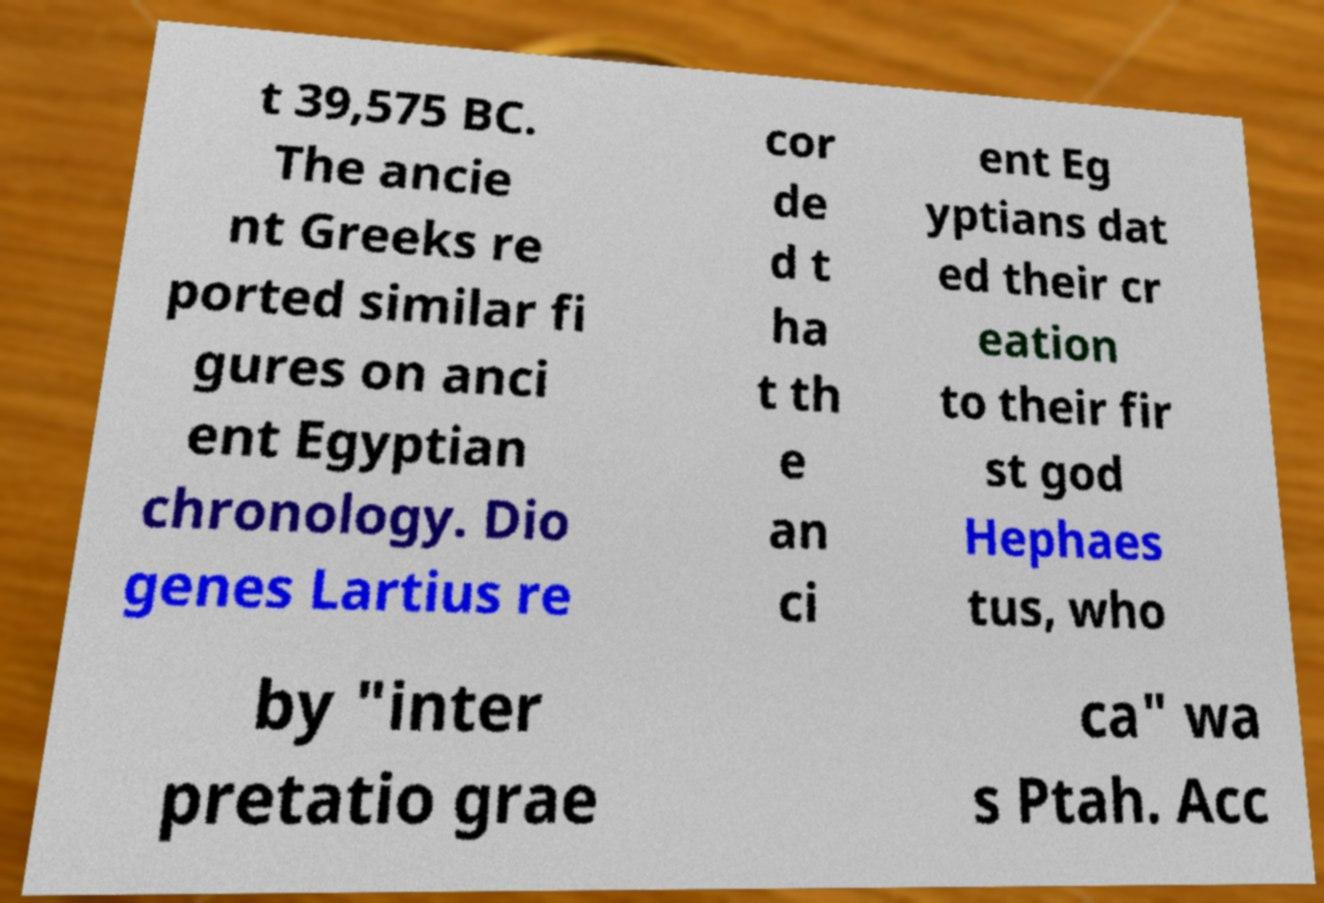Could you extract and type out the text from this image? t 39,575 BC. The ancie nt Greeks re ported similar fi gures on anci ent Egyptian chronology. Dio genes Lartius re cor de d t ha t th e an ci ent Eg yptians dat ed their cr eation to their fir st god Hephaes tus, who by "inter pretatio grae ca" wa s Ptah. Acc 